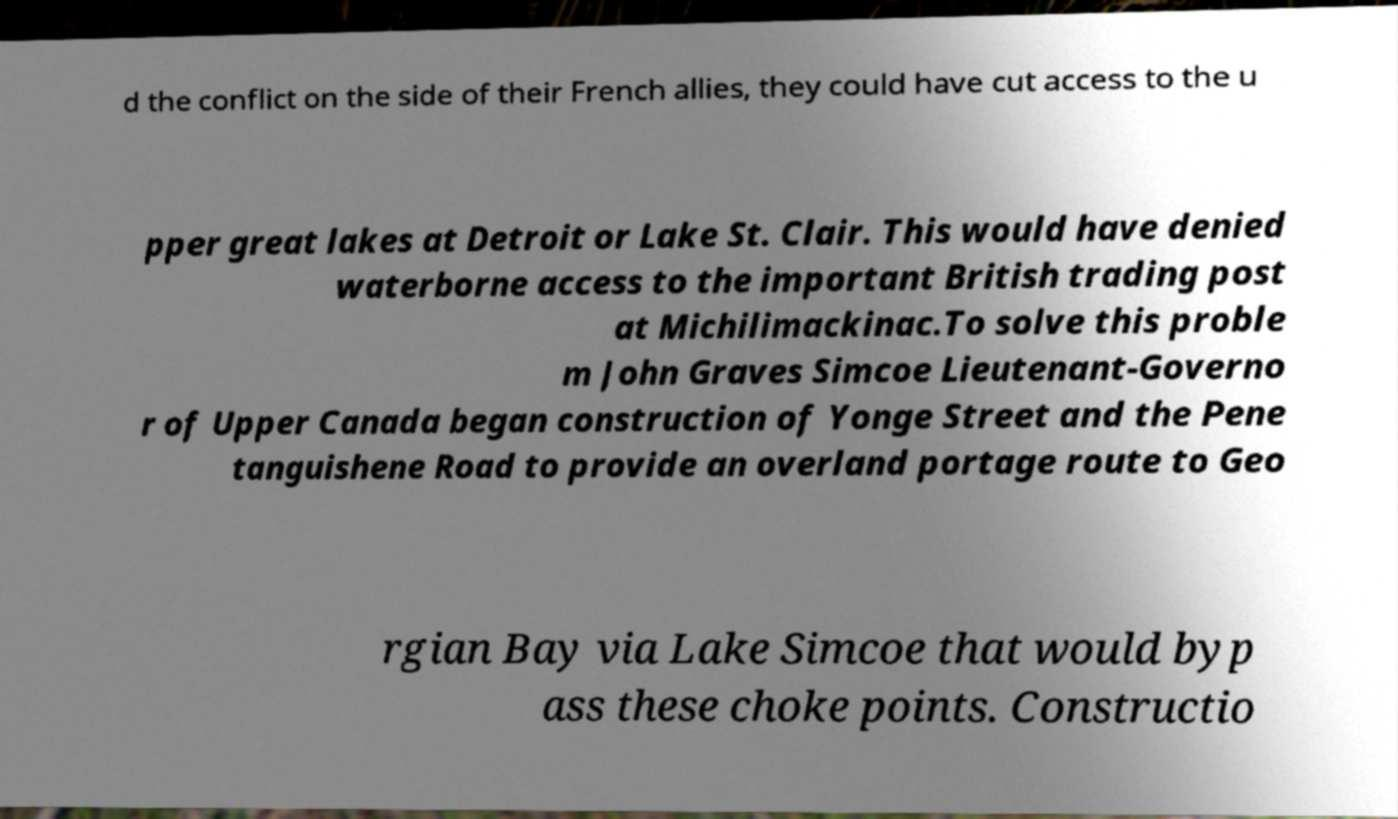What messages or text are displayed in this image? I need them in a readable, typed format. d the conflict on the side of their French allies, they could have cut access to the u pper great lakes at Detroit or Lake St. Clair. This would have denied waterborne access to the important British trading post at Michilimackinac.To solve this proble m John Graves Simcoe Lieutenant-Governo r of Upper Canada began construction of Yonge Street and the Pene tanguishene Road to provide an overland portage route to Geo rgian Bay via Lake Simcoe that would byp ass these choke points. Constructio 